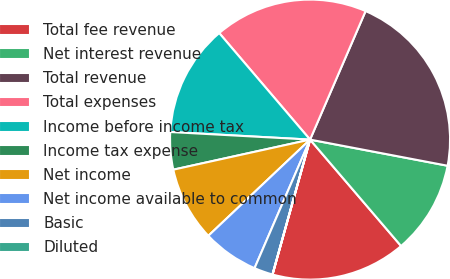<chart> <loc_0><loc_0><loc_500><loc_500><pie_chart><fcel>Total fee revenue<fcel>Net interest revenue<fcel>Total revenue<fcel>Total expenses<fcel>Income before income tax<fcel>Income tax expense<fcel>Net income<fcel>Net income available to common<fcel>Basic<fcel>Diluted<nl><fcel>15.58%<fcel>10.75%<fcel>21.5%<fcel>17.73%<fcel>12.9%<fcel>4.31%<fcel>8.61%<fcel>6.46%<fcel>2.16%<fcel>0.01%<nl></chart> 